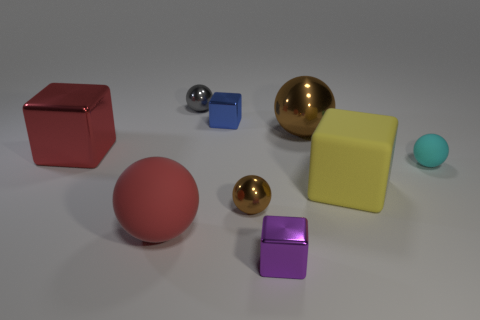Add 1 small purple metallic cubes. How many objects exist? 10 Subtract all cubes. How many objects are left? 5 Subtract 0 brown cubes. How many objects are left? 9 Subtract all small blocks. Subtract all matte objects. How many objects are left? 4 Add 6 blue metallic things. How many blue metallic things are left? 7 Add 1 big blue rubber balls. How many big blue rubber balls exist? 1 